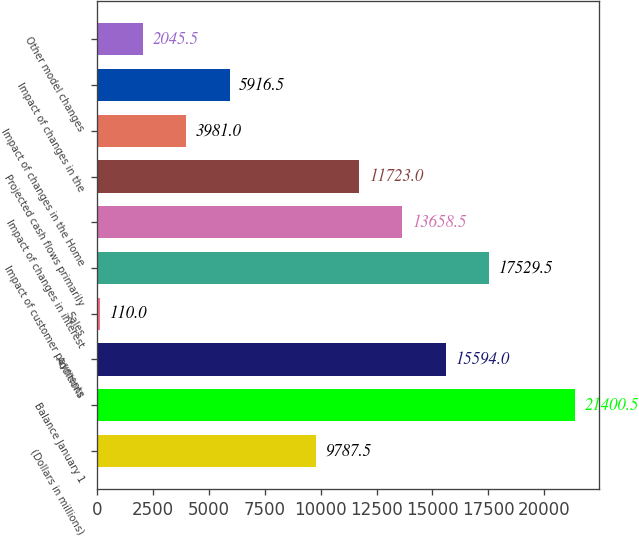Convert chart to OTSL. <chart><loc_0><loc_0><loc_500><loc_500><bar_chart><fcel>(Dollars in millions)<fcel>Balance January 1<fcel>Additions<fcel>Sales<fcel>Impact of customer payments<fcel>Impact of changes in interest<fcel>Projected cash flows primarily<fcel>Impact of changes in the Home<fcel>Impact of changes in the<fcel>Other model changes<nl><fcel>9787.5<fcel>21400.5<fcel>15594<fcel>110<fcel>17529.5<fcel>13658.5<fcel>11723<fcel>3981<fcel>5916.5<fcel>2045.5<nl></chart> 